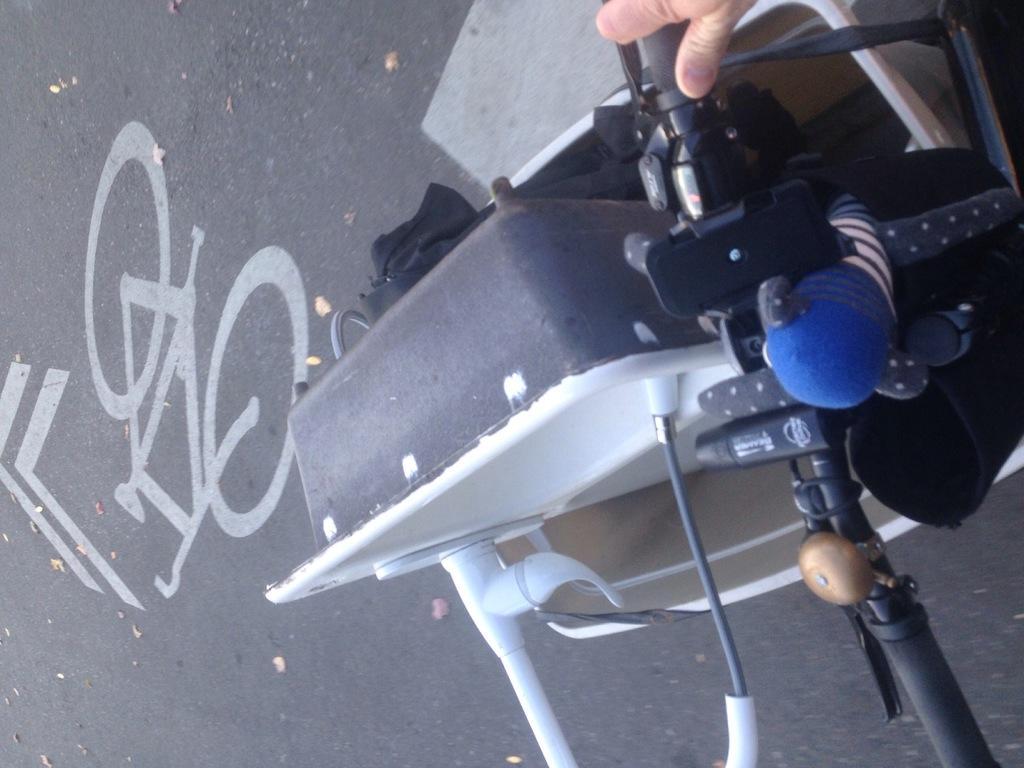Please provide a concise description of this image. There is a person cycling on the road on which, there is a painting of the bicycle. And there is an object in the basket of the bicycle. 